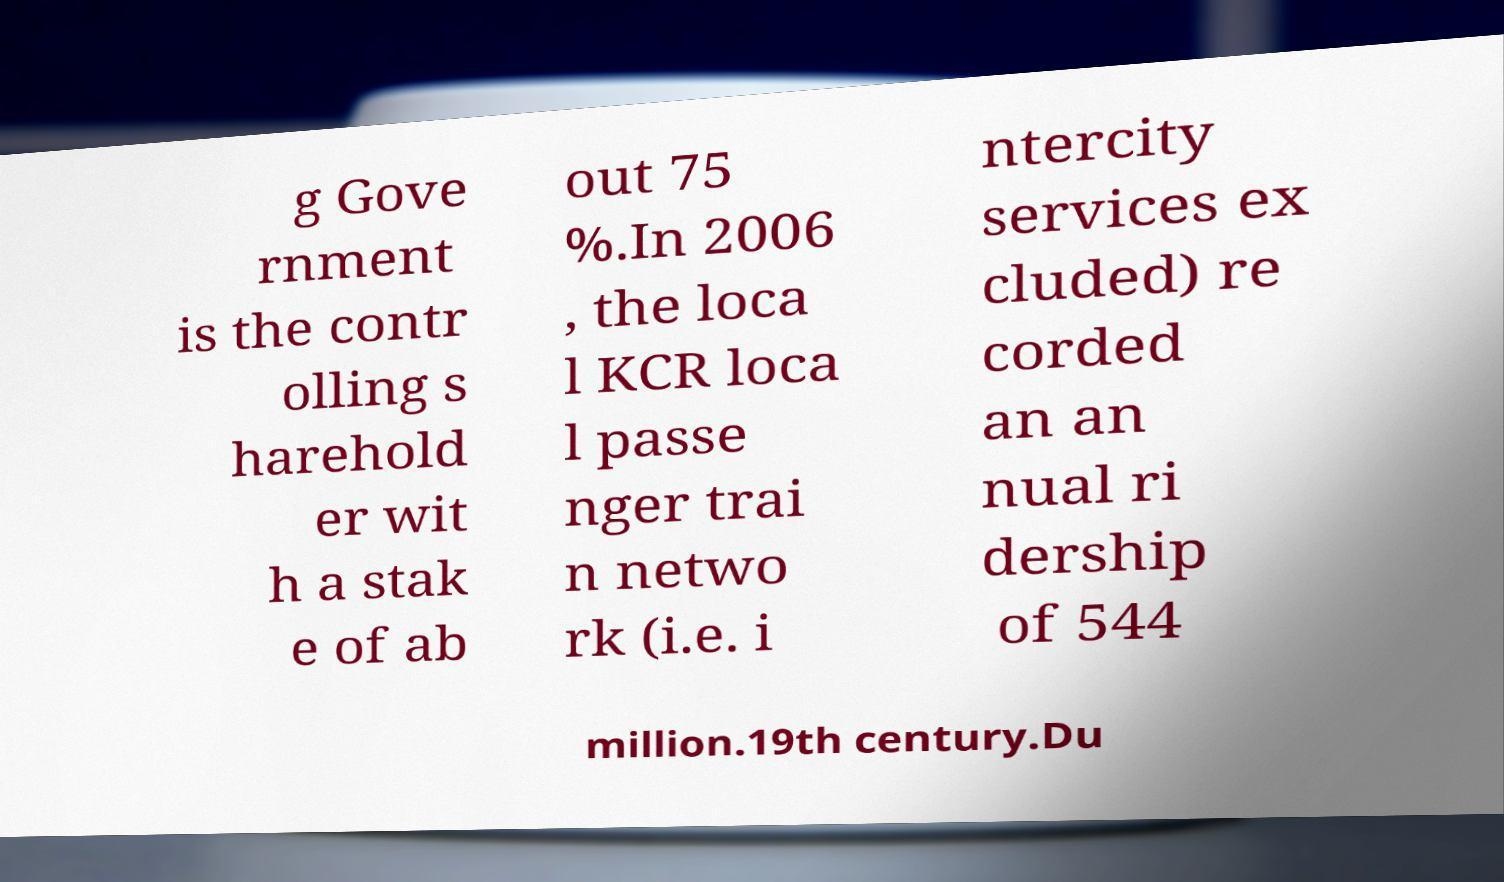Please identify and transcribe the text found in this image. g Gove rnment is the contr olling s harehold er wit h a stak e of ab out 75 %.In 2006 , the loca l KCR loca l passe nger trai n netwo rk (i.e. i ntercity services ex cluded) re corded an an nual ri dership of 544 million.19th century.Du 